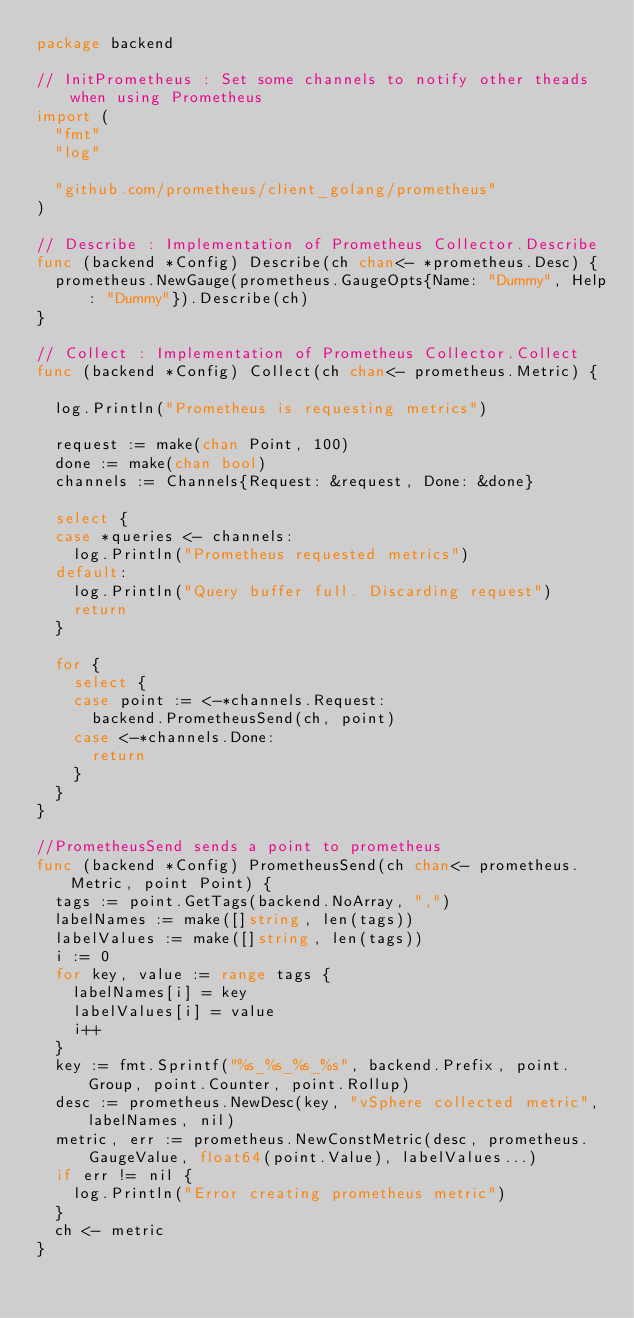<code> <loc_0><loc_0><loc_500><loc_500><_Go_>package backend

// InitPrometheus : Set some channels to notify other theads when using Prometheus
import (
	"fmt"
	"log"

	"github.com/prometheus/client_golang/prometheus"
)

// Describe : Implementation of Prometheus Collector.Describe
func (backend *Config) Describe(ch chan<- *prometheus.Desc) {
	prometheus.NewGauge(prometheus.GaugeOpts{Name: "Dummy", Help: "Dummy"}).Describe(ch)
}

// Collect : Implementation of Prometheus Collector.Collect
func (backend *Config) Collect(ch chan<- prometheus.Metric) {

	log.Println("Prometheus is requesting metrics")

	request := make(chan Point, 100)
	done := make(chan bool)
	channels := Channels{Request: &request, Done: &done}

	select {
	case *queries <- channels:
		log.Println("Prometheus requested metrics")
	default:
		log.Println("Query buffer full. Discarding request")
		return
	}

	for {
		select {
		case point := <-*channels.Request:
			backend.PrometheusSend(ch, point)
		case <-*channels.Done:
			return
		}
	}
}

//PrometheusSend sends a point to prometheus
func (backend *Config) PrometheusSend(ch chan<- prometheus.Metric, point Point) {
	tags := point.GetTags(backend.NoArray, ",")
	labelNames := make([]string, len(tags))
	labelValues := make([]string, len(tags))
	i := 0
	for key, value := range tags {
		labelNames[i] = key
		labelValues[i] = value
		i++
	}
	key := fmt.Sprintf("%s_%s_%s_%s", backend.Prefix, point.Group, point.Counter, point.Rollup)
	desc := prometheus.NewDesc(key, "vSphere collected metric", labelNames, nil)
	metric, err := prometheus.NewConstMetric(desc, prometheus.GaugeValue, float64(point.Value), labelValues...)
	if err != nil {
		log.Println("Error creating prometheus metric")
	}
	ch <- metric
}
</code> 